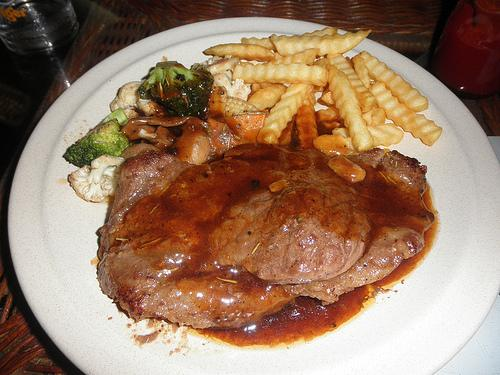Count how many food items with sauce are mentioned in the given information. There are six food items with sauce mentioned: meat, french fries, broccoli, mushrooms, steak, and cauliflower. List all the food items present on the plate in the image. French fries, broccoli, cauliflower, meat, mushrooms, and sauce. What specific type of french fries is served next to the steak? Crinkle french fries are served next to the steak. Discuss the object interactions, particularly between the sauce and other elements on the plate. The sauce interacts with various elements on the plate, covering the meat, french fries, broccoli, mushrooms, and steak, and is also present under the steak. What type of sauce is mentioned in the jar on the table? There is a red sauce mentioned in the jar on the table. Identify the state of the meat and the vegetables served on that plate. The meat is sliced and has gravy over it, while the broccoli and cauliflower are grilled. Please provide the color scheme for the following: plate, table, sauce on fries, and sauce on meat. The plate is white, the table is wicker and brown, sauce on fries is brown, and sauce on the meat is brown. In one sentence, discuss the table on which the plate is placed. The table is a wicker table with a brown design, and there is an empty glass and a napkin on it. Analyze and describe the steak's appearance on the plate. The steak in the image is juicy, sliced, and has sauce and a bit of dry herb on top. 